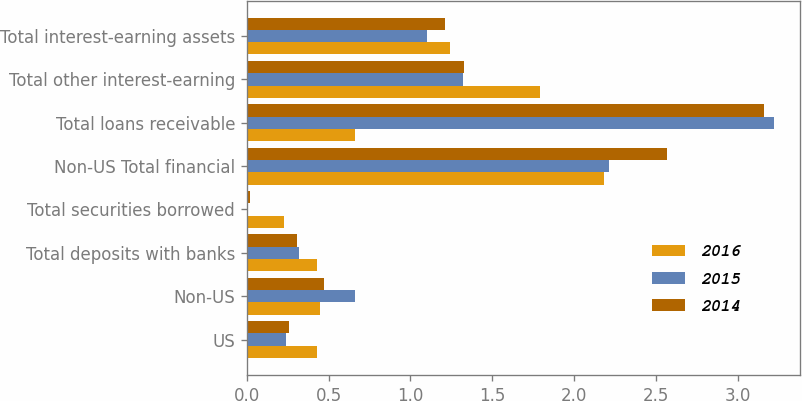Convert chart to OTSL. <chart><loc_0><loc_0><loc_500><loc_500><stacked_bar_chart><ecel><fcel>US<fcel>Non-US<fcel>Total deposits with banks<fcel>Total securities borrowed<fcel>Non-US Total financial<fcel>Total loans receivable<fcel>Total other interest-earning<fcel>Total interest-earning assets<nl><fcel>2016<fcel>0.43<fcel>0.45<fcel>0.43<fcel>0.23<fcel>2.18<fcel>0.66<fcel>1.79<fcel>1.24<nl><fcel>2015<fcel>0.24<fcel>0.66<fcel>0.32<fcel>0.01<fcel>2.21<fcel>3.22<fcel>1.32<fcel>1.1<nl><fcel>2014<fcel>0.26<fcel>0.47<fcel>0.31<fcel>0.02<fcel>2.57<fcel>3.16<fcel>1.33<fcel>1.21<nl></chart> 